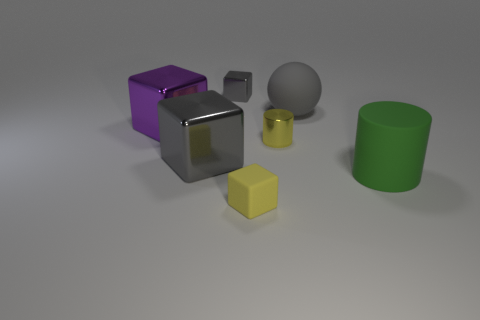Subtract all big gray metallic blocks. How many blocks are left? 3 Add 1 big brown cylinders. How many objects exist? 8 Subtract all purple cubes. How many cubes are left? 3 Subtract all cubes. How many objects are left? 3 Subtract 2 cylinders. How many cylinders are left? 0 Subtract all purple spheres. How many gray cubes are left? 2 Subtract all matte objects. Subtract all big gray cubes. How many objects are left? 3 Add 5 small gray cubes. How many small gray cubes are left? 6 Add 6 cyan metal cylinders. How many cyan metal cylinders exist? 6 Subtract 0 brown spheres. How many objects are left? 7 